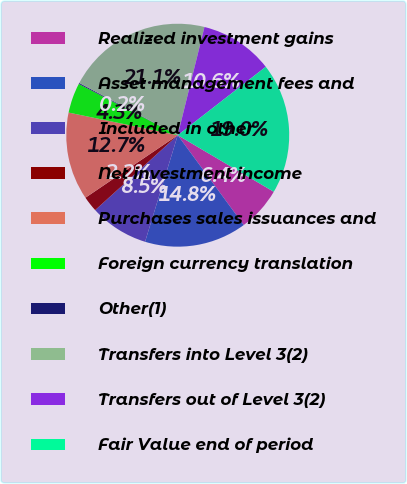Convert chart. <chart><loc_0><loc_0><loc_500><loc_500><pie_chart><fcel>Realized investment gains<fcel>Asset management fees and<fcel>Included in other<fcel>Net investment income<fcel>Purchases sales issuances and<fcel>Foreign currency translation<fcel>Other(1)<fcel>Transfers into Level 3(2)<fcel>Transfers out of Level 3(2)<fcel>Fair Value end of period<nl><fcel>6.44%<fcel>14.82%<fcel>8.54%<fcel>2.25%<fcel>12.73%<fcel>4.35%<fcel>0.15%<fcel>21.1%<fcel>10.63%<fcel>18.99%<nl></chart> 